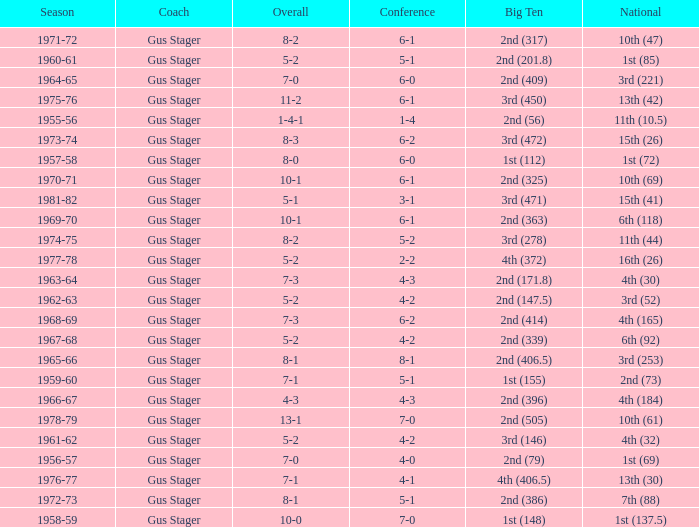What is the Coach with a Big Ten that is 2nd (79)? Gus Stager. 